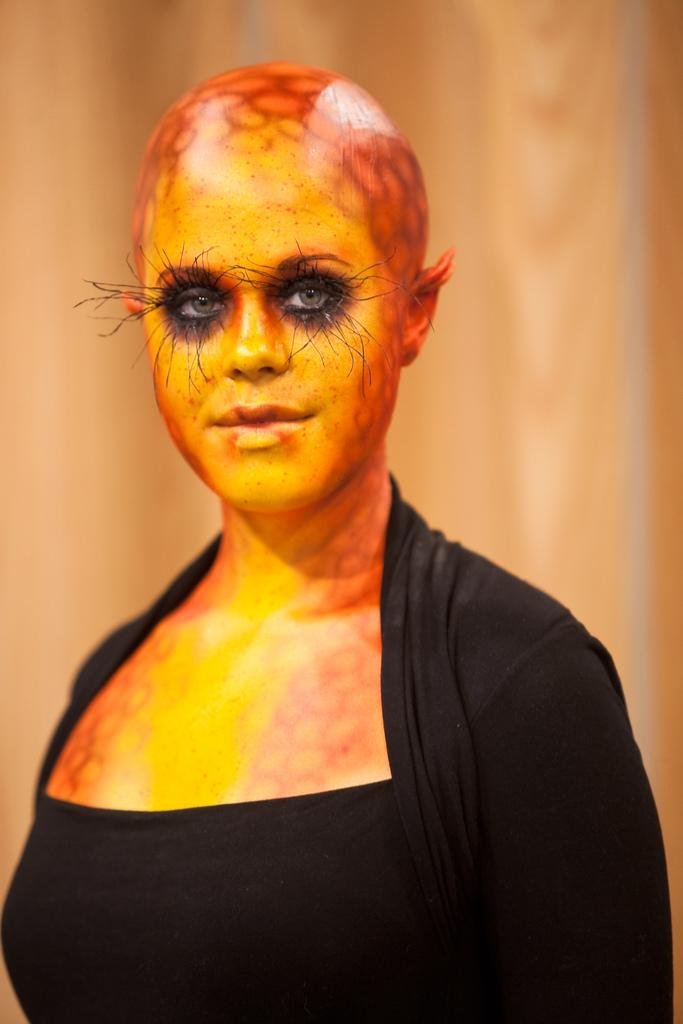What is the main subject of the image? There is a person in the image. What is unique about the person's appearance? The person has a painting on their skin. What color is the dress the person is wearing? The person is wearing a black dress. How would you describe the background of the image? The background of the image is blurred. What type of blood is visible on the person's skin in the image? There is no blood visible on the person's skin in the image; they have a painting on their skin. What kind of mark can be seen on the person's skin in the image? There is no mark visible on the person's skin in the image; they have a painting on their skin. 